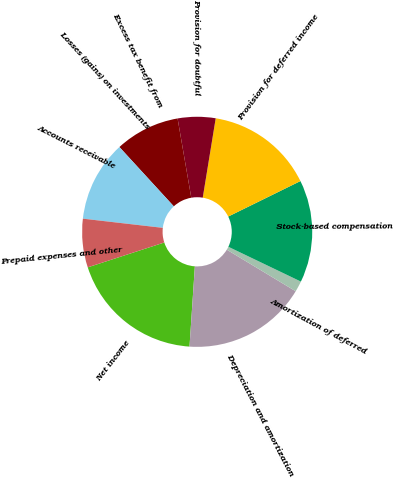Convert chart. <chart><loc_0><loc_0><loc_500><loc_500><pie_chart><fcel>Net income<fcel>Depreciation and amortization<fcel>Amortization of deferred<fcel>Stock-based compensation<fcel>Provision for deferred income<fcel>Provision for doubtful<fcel>Excess tax benefit from<fcel>Losses (gains) on investments<fcel>Accounts receivable<fcel>Prepaid expenses and other<nl><fcel>18.94%<fcel>17.42%<fcel>1.52%<fcel>14.39%<fcel>15.15%<fcel>5.3%<fcel>9.09%<fcel>0.0%<fcel>11.36%<fcel>6.82%<nl></chart> 